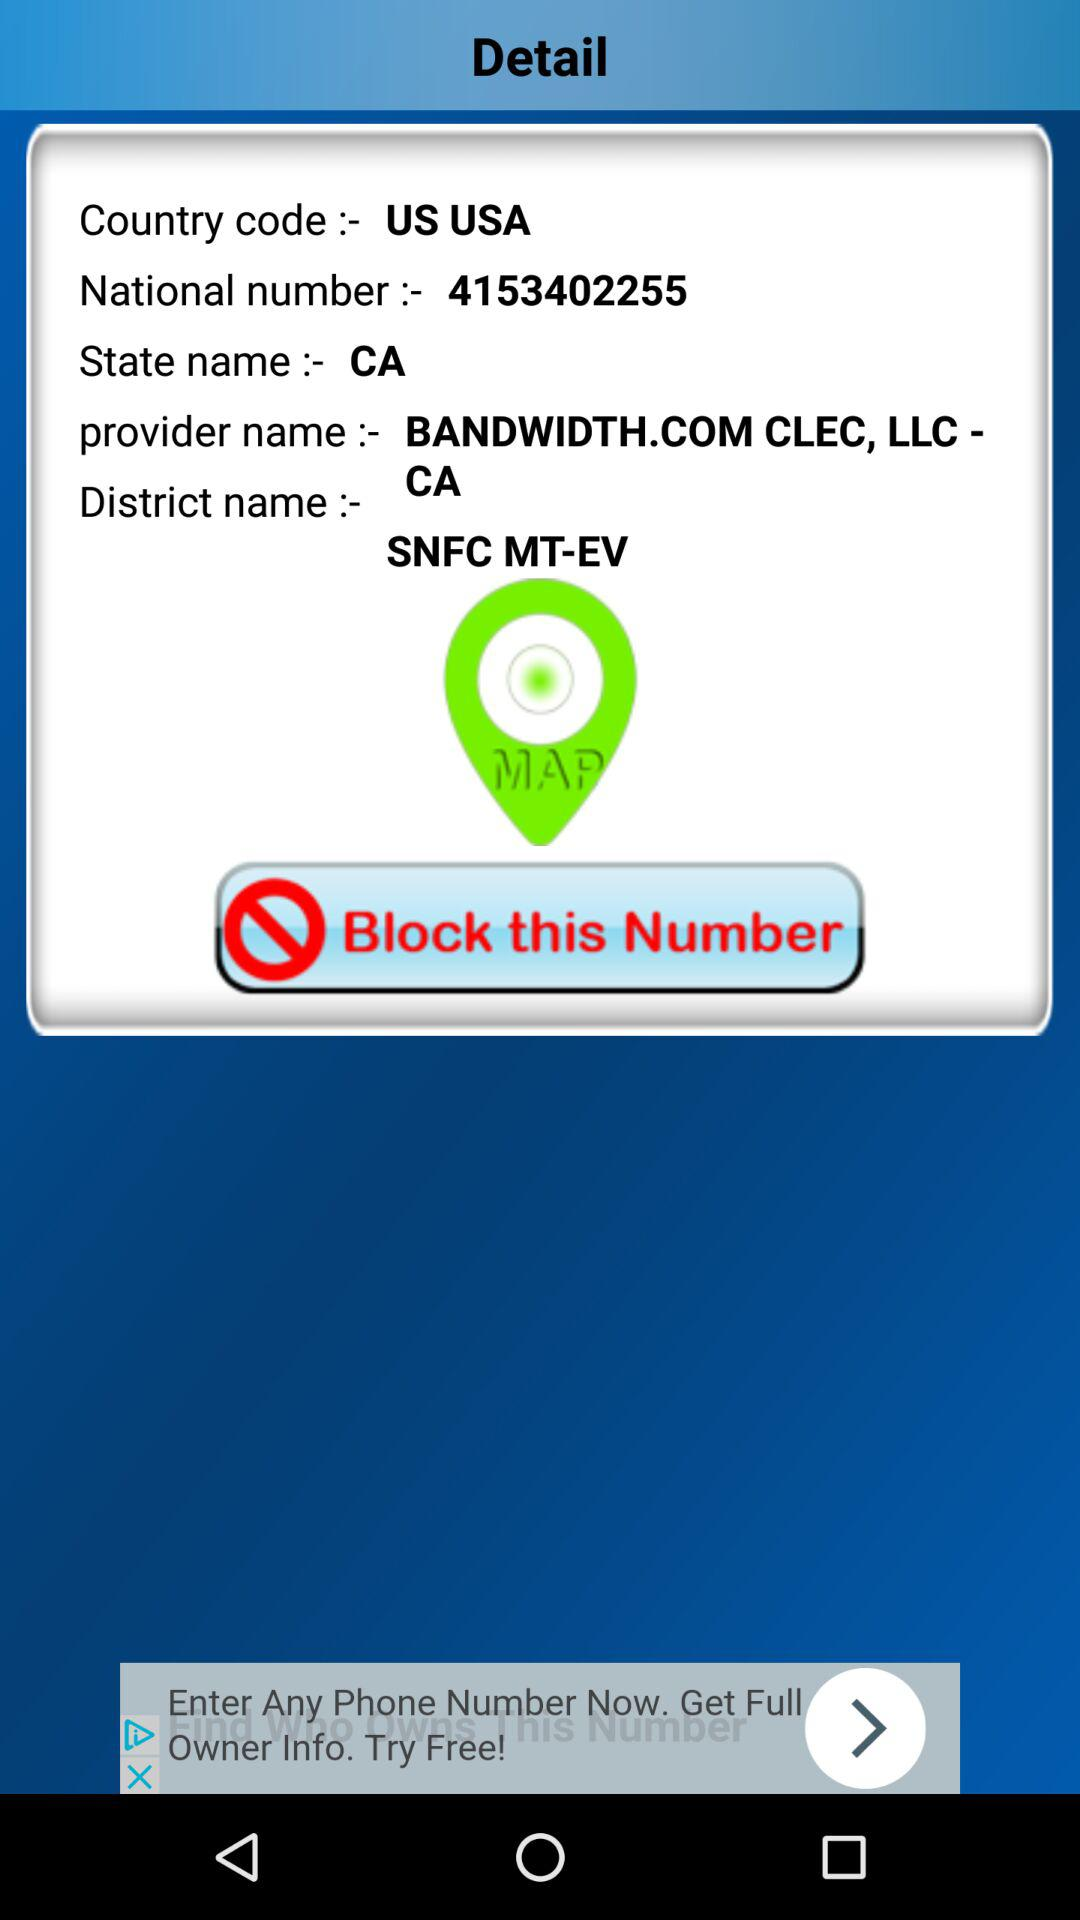What is the provider name? The provider name is "BANDWIDTH.COM CLEC, LLC". 